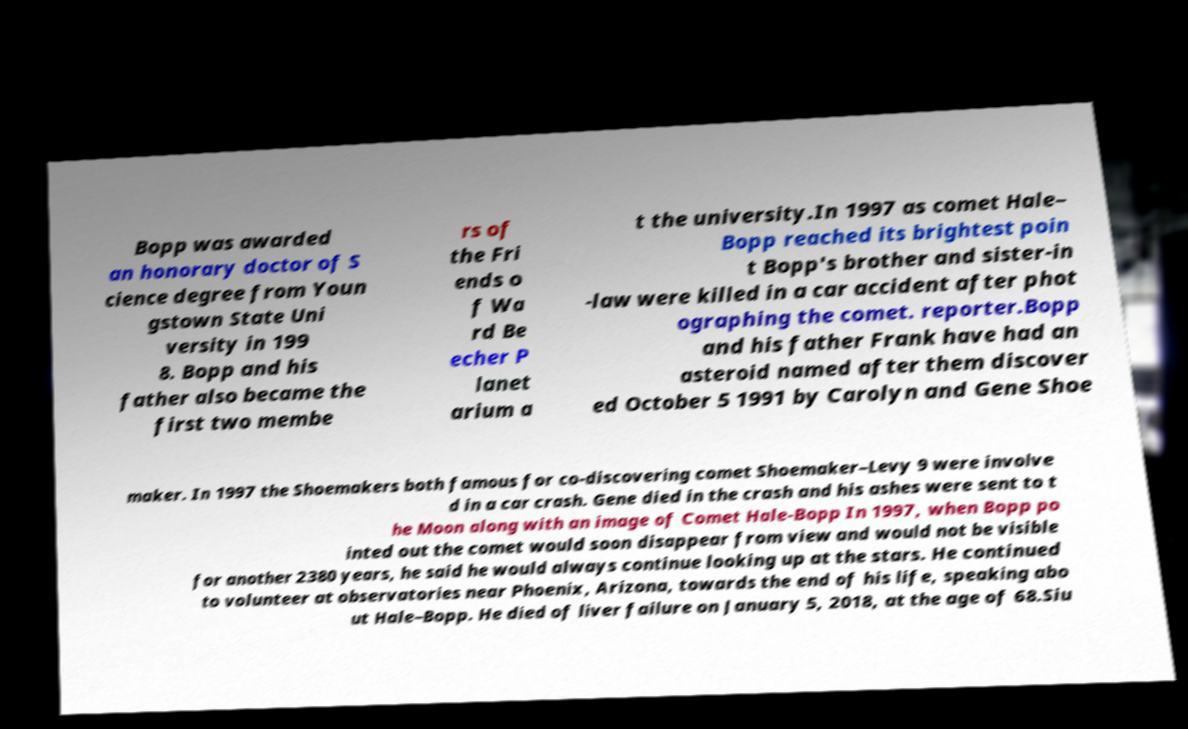Please identify and transcribe the text found in this image. Bopp was awarded an honorary doctor of S cience degree from Youn gstown State Uni versity in 199 8. Bopp and his father also became the first two membe rs of the Fri ends o f Wa rd Be echer P lanet arium a t the university.In 1997 as comet Hale– Bopp reached its brightest poin t Bopp's brother and sister-in -law were killed in a car accident after phot ographing the comet. reporter.Bopp and his father Frank have had an asteroid named after them discover ed October 5 1991 by Carolyn and Gene Shoe maker. In 1997 the Shoemakers both famous for co-discovering comet Shoemaker–Levy 9 were involve d in a car crash. Gene died in the crash and his ashes were sent to t he Moon along with an image of Comet Hale-Bopp In 1997, when Bopp po inted out the comet would soon disappear from view and would not be visible for another 2380 years, he said he would always continue looking up at the stars. He continued to volunteer at observatories near Phoenix, Arizona, towards the end of his life, speaking abo ut Hale–Bopp. He died of liver failure on January 5, 2018, at the age of 68.Siu 